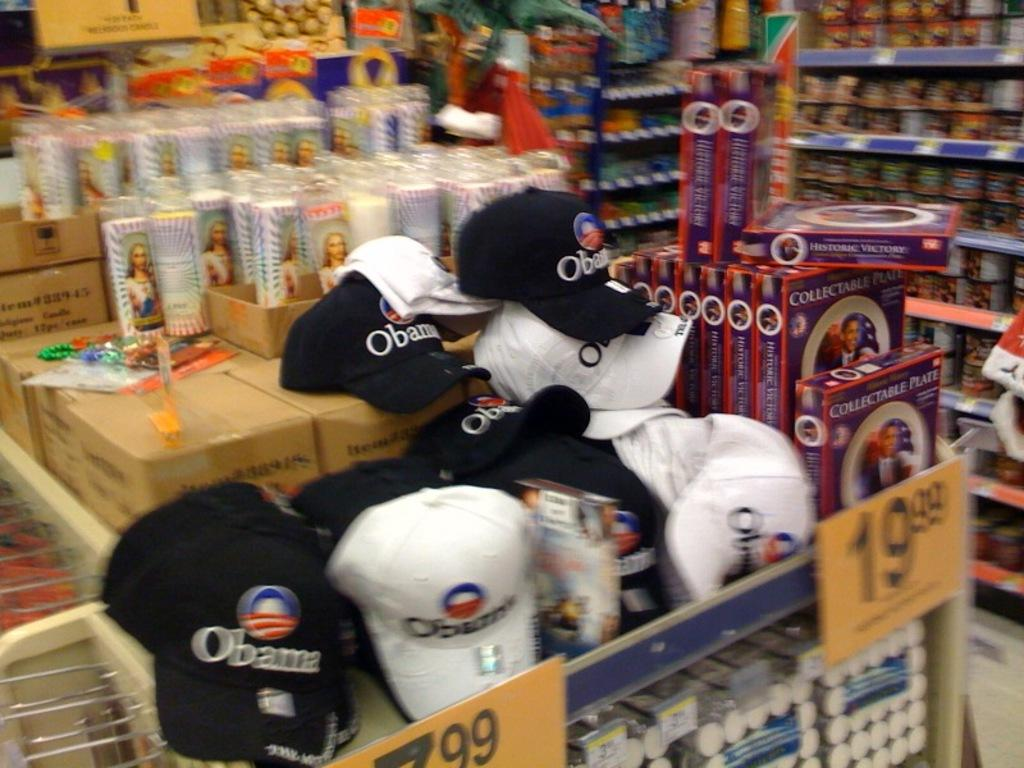Provide a one-sentence caption for the provided image. A stack of Obama hats for the upcoming presidential election. 